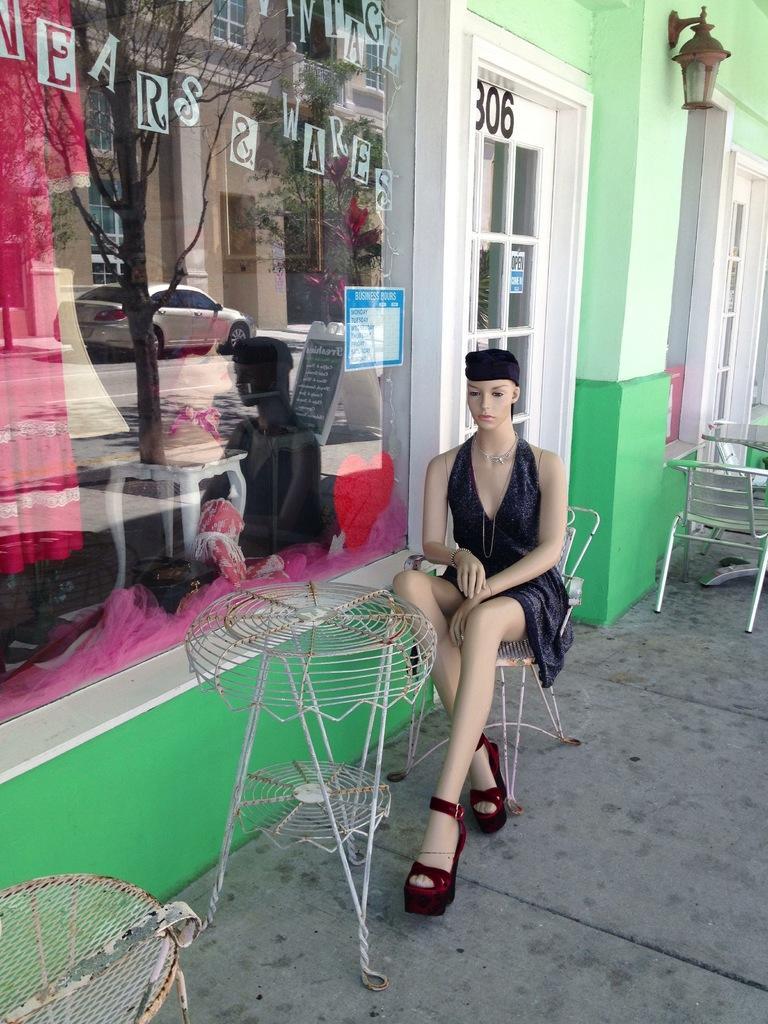Please provide a concise description of this image. In the foreground I can see a mannequin on a chair in front of a table. In the background I can see a wall, door, glass window in which I can see trees, buildings and a car. This image is taken may be during a day. 